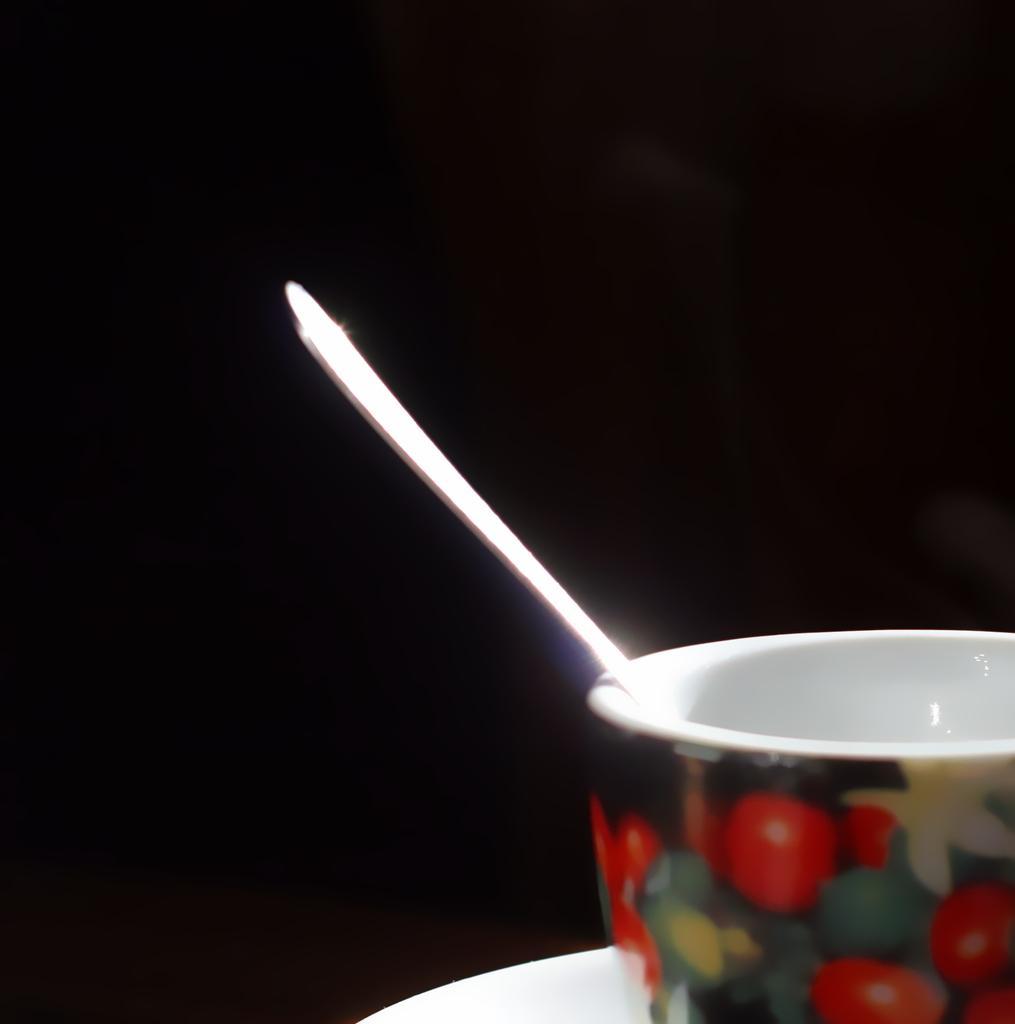Could you give a brief overview of what you see in this image? In this image we can see a bowl with a design and a spoon in the bow and a dark background. 